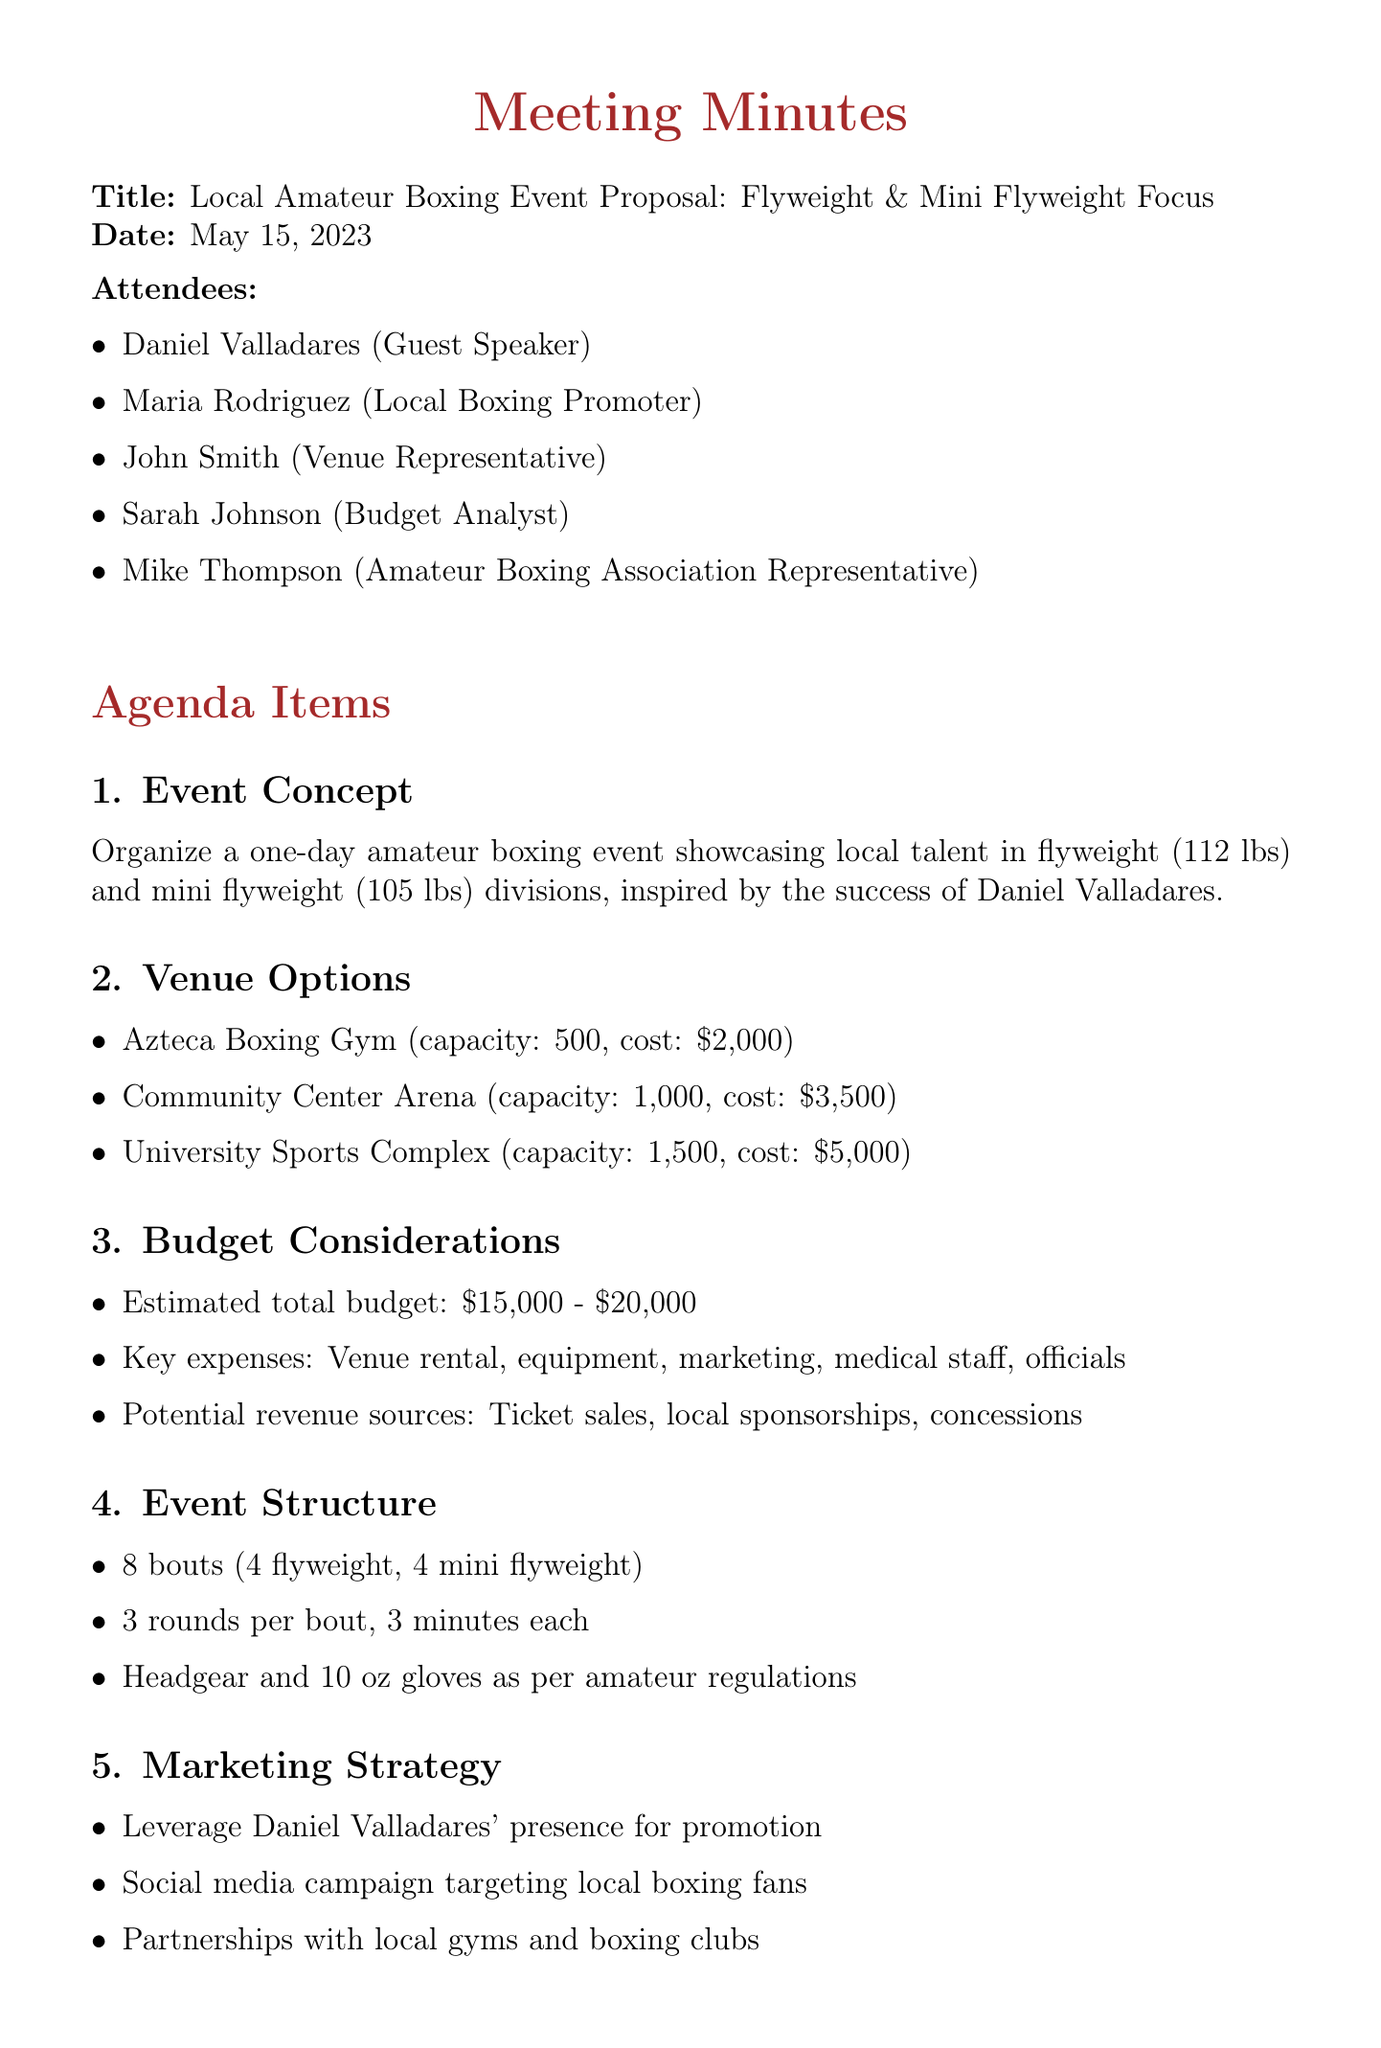what is the date of the meeting? The date of the meeting is clearly stated at the beginning of the document.
Answer: May 15, 2023 who is the guest speaker? The guest speaker is listed among the attendees of the meeting.
Answer: Daniel Valladares how many bouts are scheduled for the event? The number of bouts is explicitly mentioned in the event structure section of the document.
Answer: 8 bouts what is the capacity of the Community Center Arena? The capacity of the Community Center Arena is provided as a detail for venue options.
Answer: 1,000 what is the estimated total budget range? The estimated total budget range is specified in the budget considerations section of the document.
Answer: $15,000 - $20,000 what is the purpose of having a medical team on-site? The document discusses safety and regulations, indicating the need for safety measures in the event.
Answer: Safety regulations what marketing strategy involves Daniel Valladares? The marketing strategy section highlights using a specific approach involving Daniel Valladares.
Answer: Leverage his presence what are the next steps listed in the meeting? The next steps outline what actions need to be taken after the meeting, stated in a specific section.
Answer: Finalize venue selection how many rounds per bout are scheduled? The details under event structure directly state the number of rounds per bout.
Answer: 3 rounds 